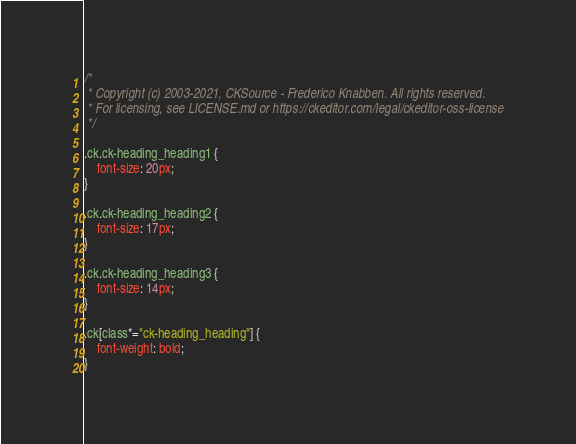Convert code to text. <code><loc_0><loc_0><loc_500><loc_500><_CSS_>/*
 * Copyright (c) 2003-2021, CKSource - Frederico Knabben. All rights reserved.
 * For licensing, see LICENSE.md or https://ckeditor.com/legal/ckeditor-oss-license
 */

.ck.ck-heading_heading1 {
	font-size: 20px;
}

.ck.ck-heading_heading2 {
	font-size: 17px;
}

.ck.ck-heading_heading3 {
	font-size: 14px;
}

.ck[class*="ck-heading_heading"] {
	font-weight: bold;
}
</code> 